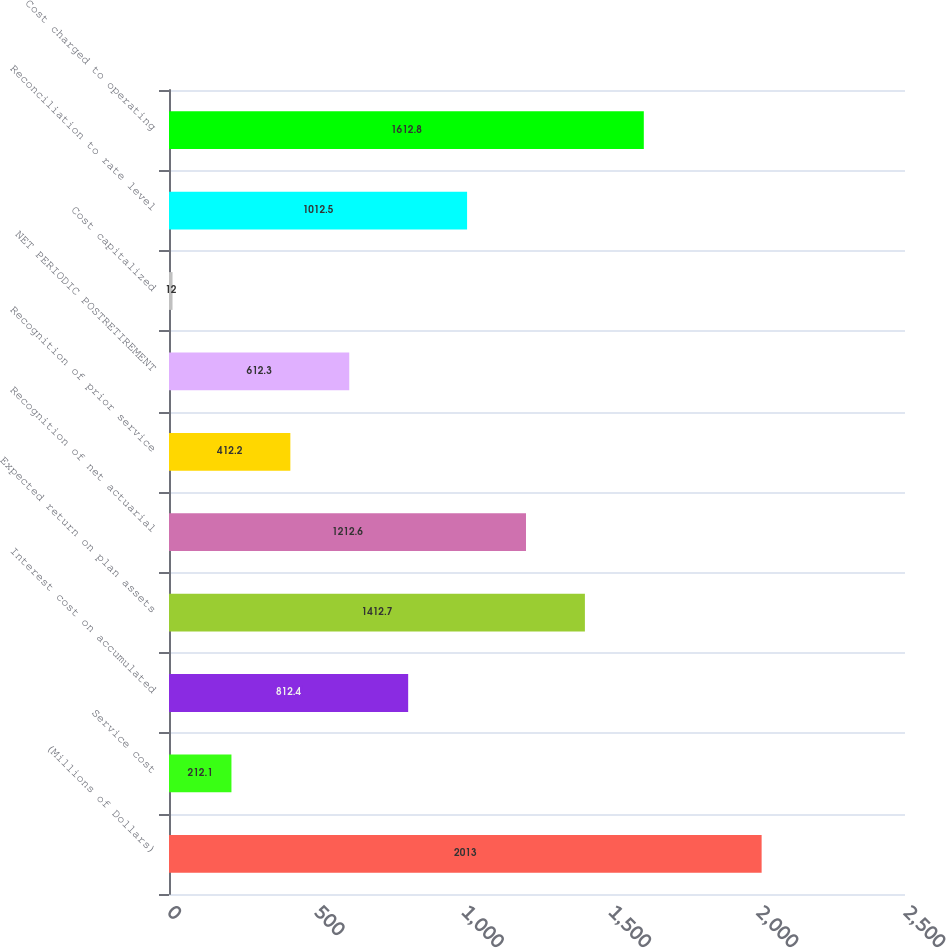Convert chart to OTSL. <chart><loc_0><loc_0><loc_500><loc_500><bar_chart><fcel>(Millions of Dollars)<fcel>Service cost<fcel>Interest cost on accumulated<fcel>Expected return on plan assets<fcel>Recognition of net actuarial<fcel>Recognition of prior service<fcel>NET PERIODIC POSTRETIREMENT<fcel>Cost capitalized<fcel>Reconciliation to rate level<fcel>Cost charged to operating<nl><fcel>2013<fcel>212.1<fcel>812.4<fcel>1412.7<fcel>1212.6<fcel>412.2<fcel>612.3<fcel>12<fcel>1012.5<fcel>1612.8<nl></chart> 